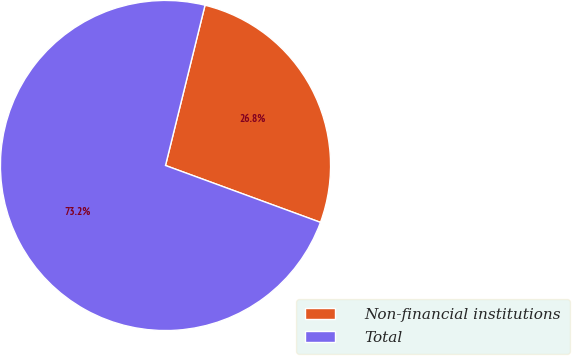Convert chart. <chart><loc_0><loc_0><loc_500><loc_500><pie_chart><fcel>Non-financial institutions<fcel>Total<nl><fcel>26.75%<fcel>73.25%<nl></chart> 